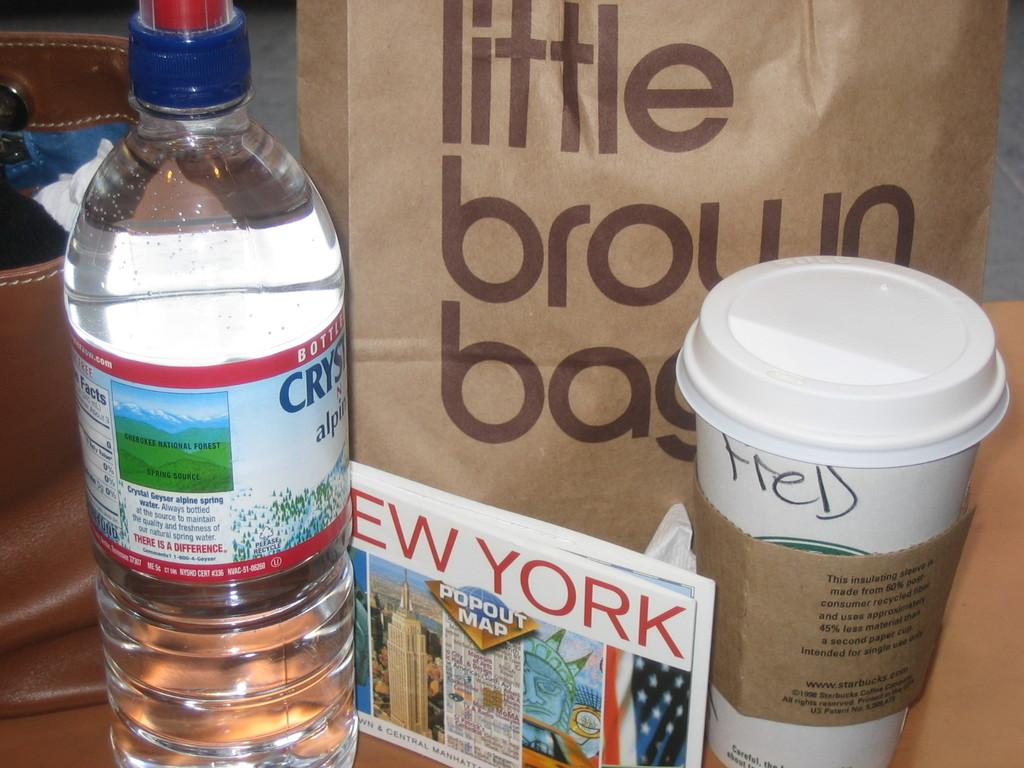<image>
Present a compact description of the photo's key features. A bottle of water and coffee cup sit in front of a bag labeled "Little Brown Bag." 